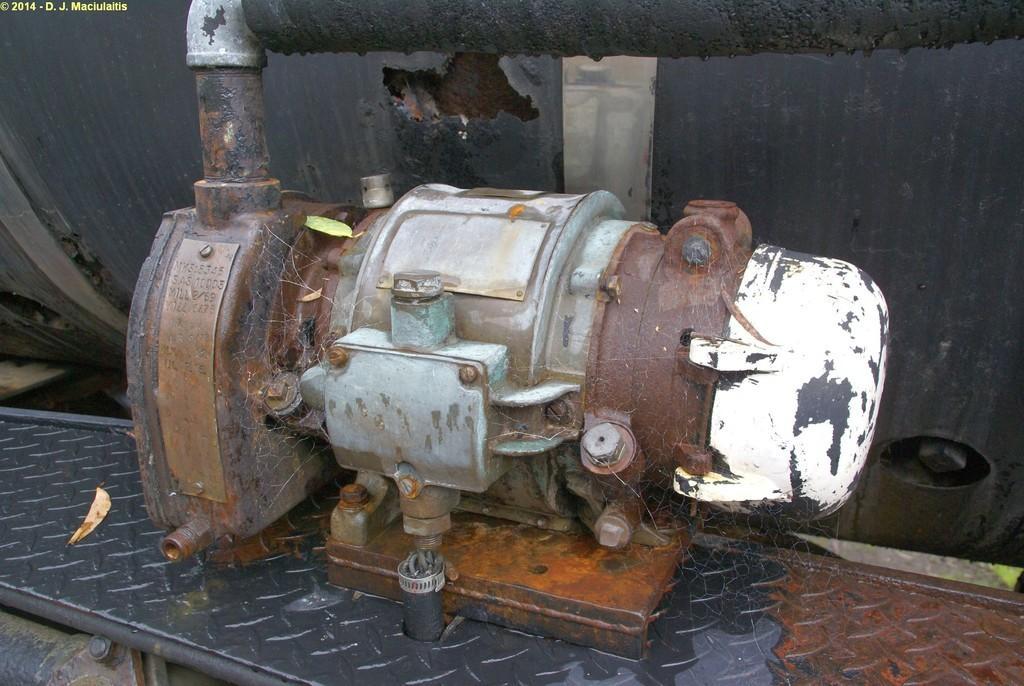Describe this image in one or two sentences. In this picture we can see a mortar and there is a rust formed on it. 